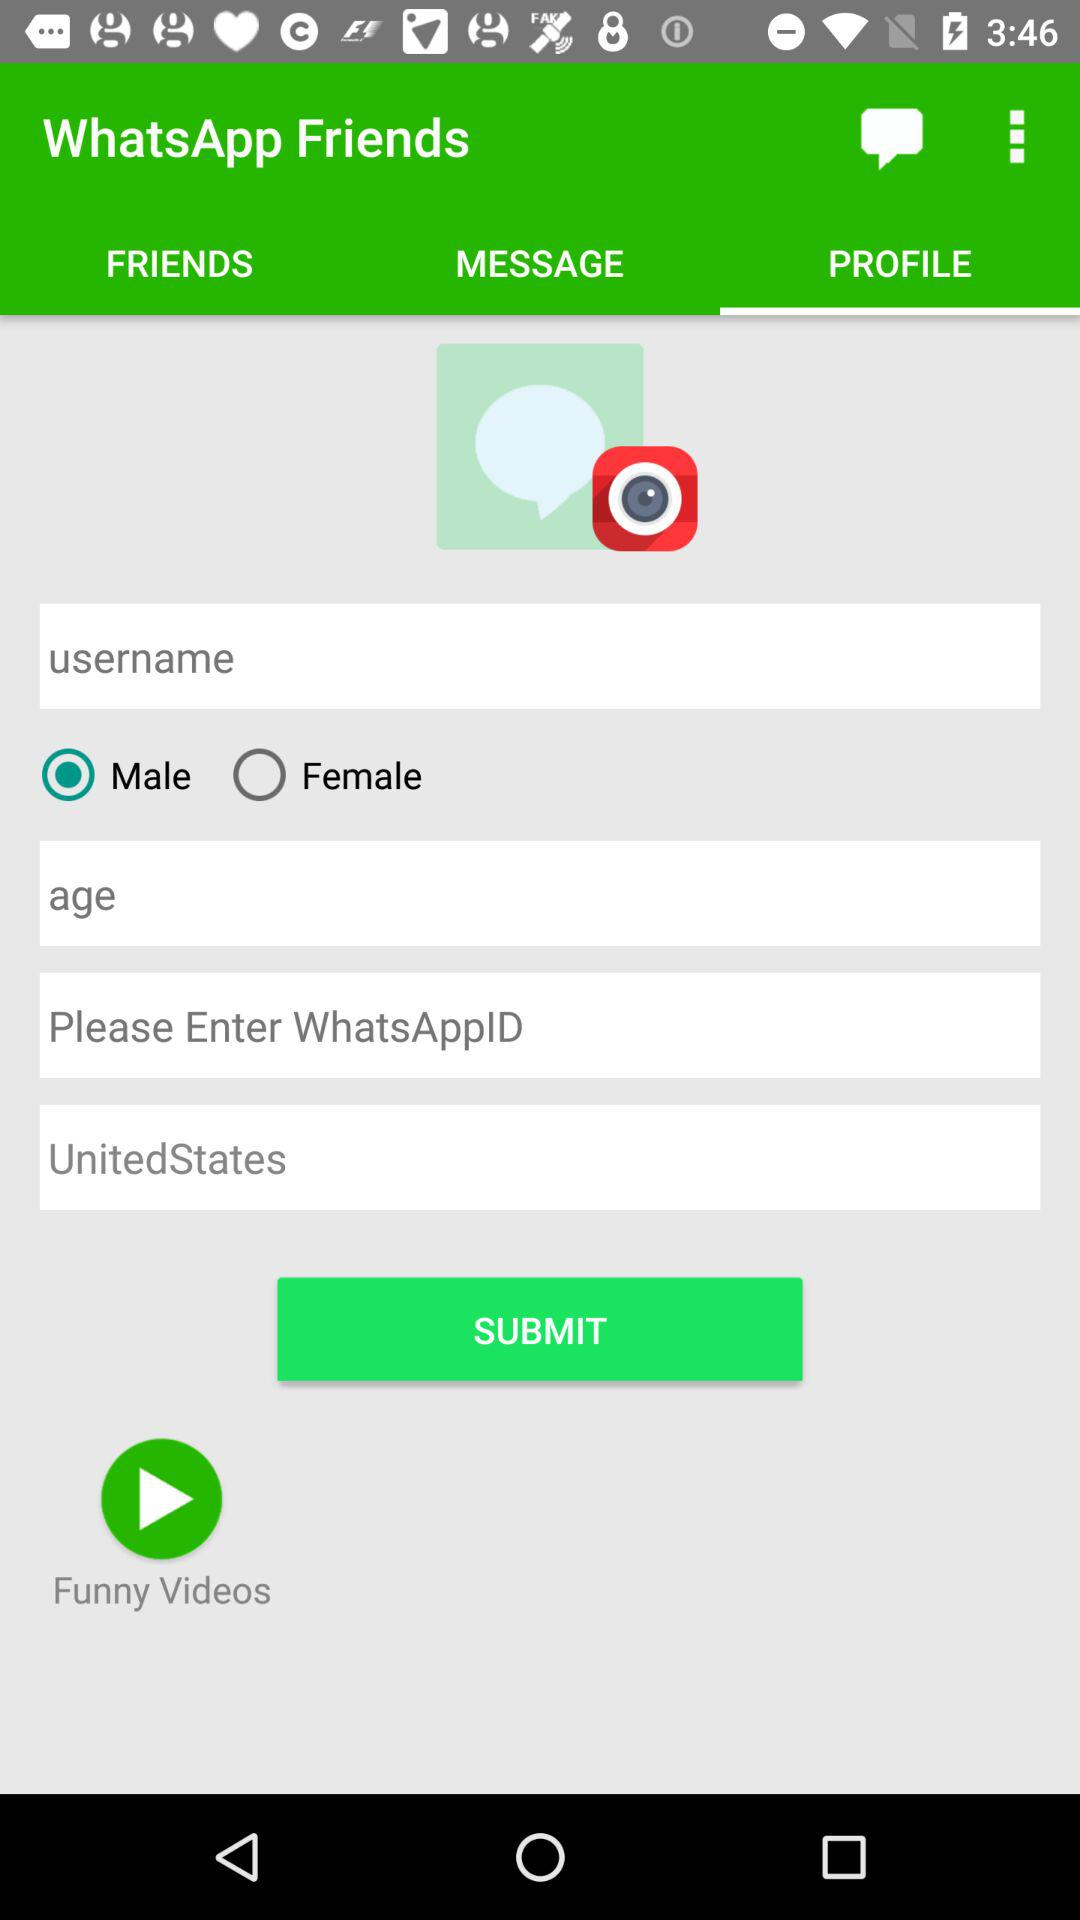What is the selected gender? The selected gender is male. 